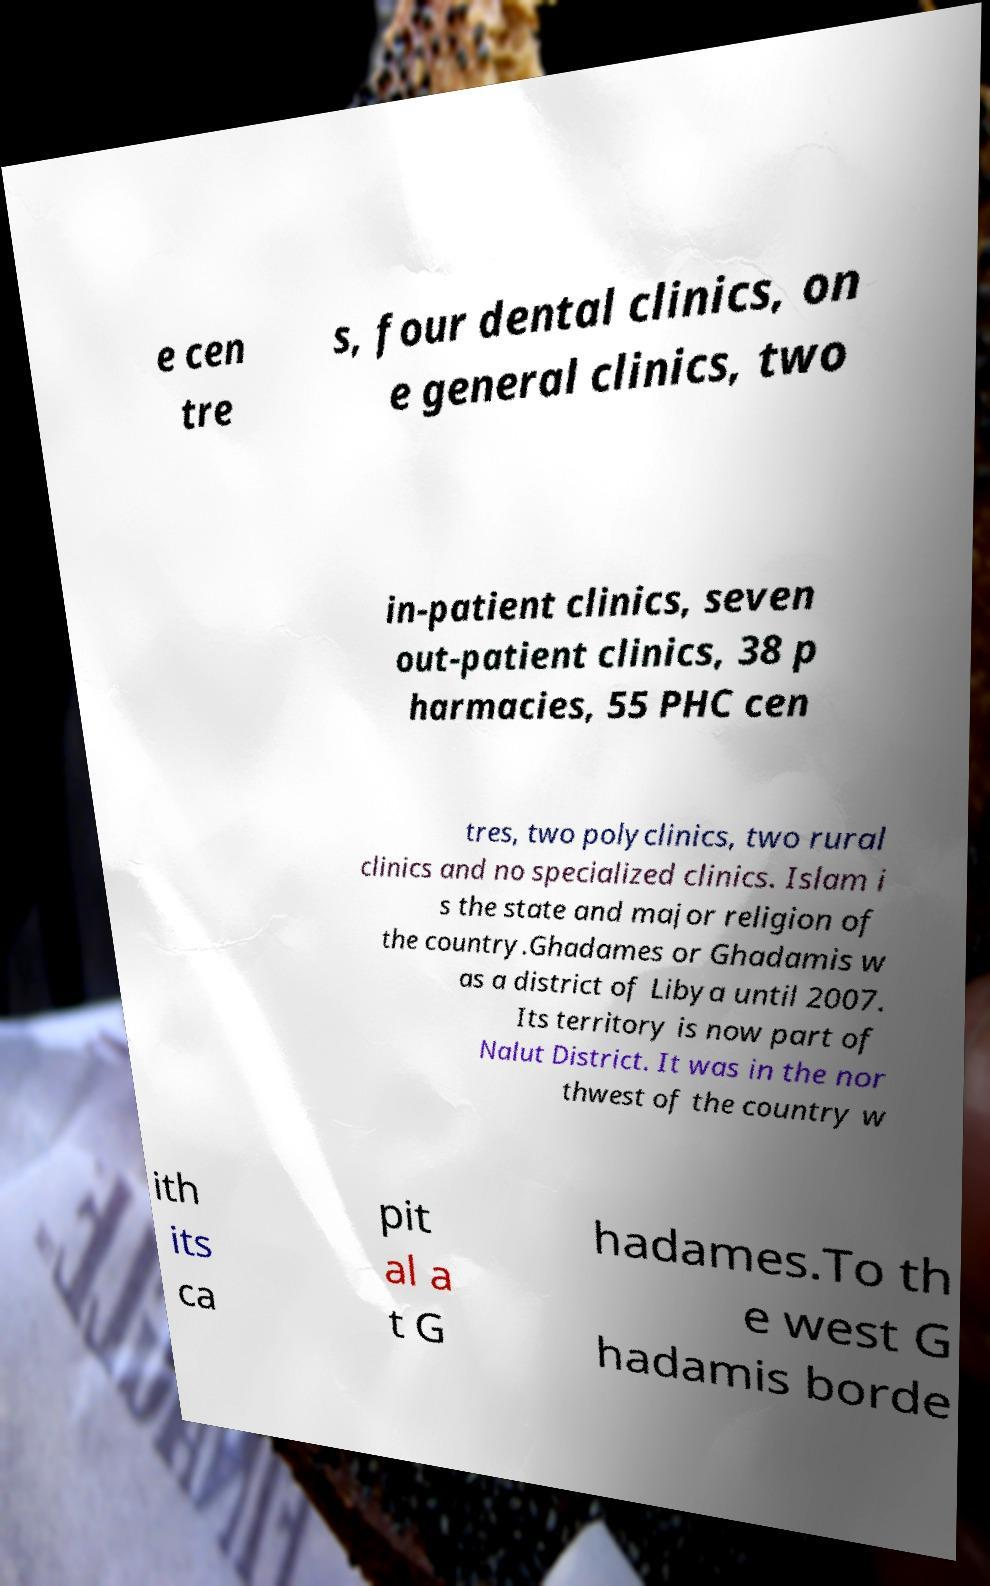What messages or text are displayed in this image? I need them in a readable, typed format. e cen tre s, four dental clinics, on e general clinics, two in-patient clinics, seven out-patient clinics, 38 p harmacies, 55 PHC cen tres, two polyclinics, two rural clinics and no specialized clinics. Islam i s the state and major religion of the country.Ghadames or Ghadamis w as a district of Libya until 2007. Its territory is now part of Nalut District. It was in the nor thwest of the country w ith its ca pit al a t G hadames.To th e west G hadamis borde 